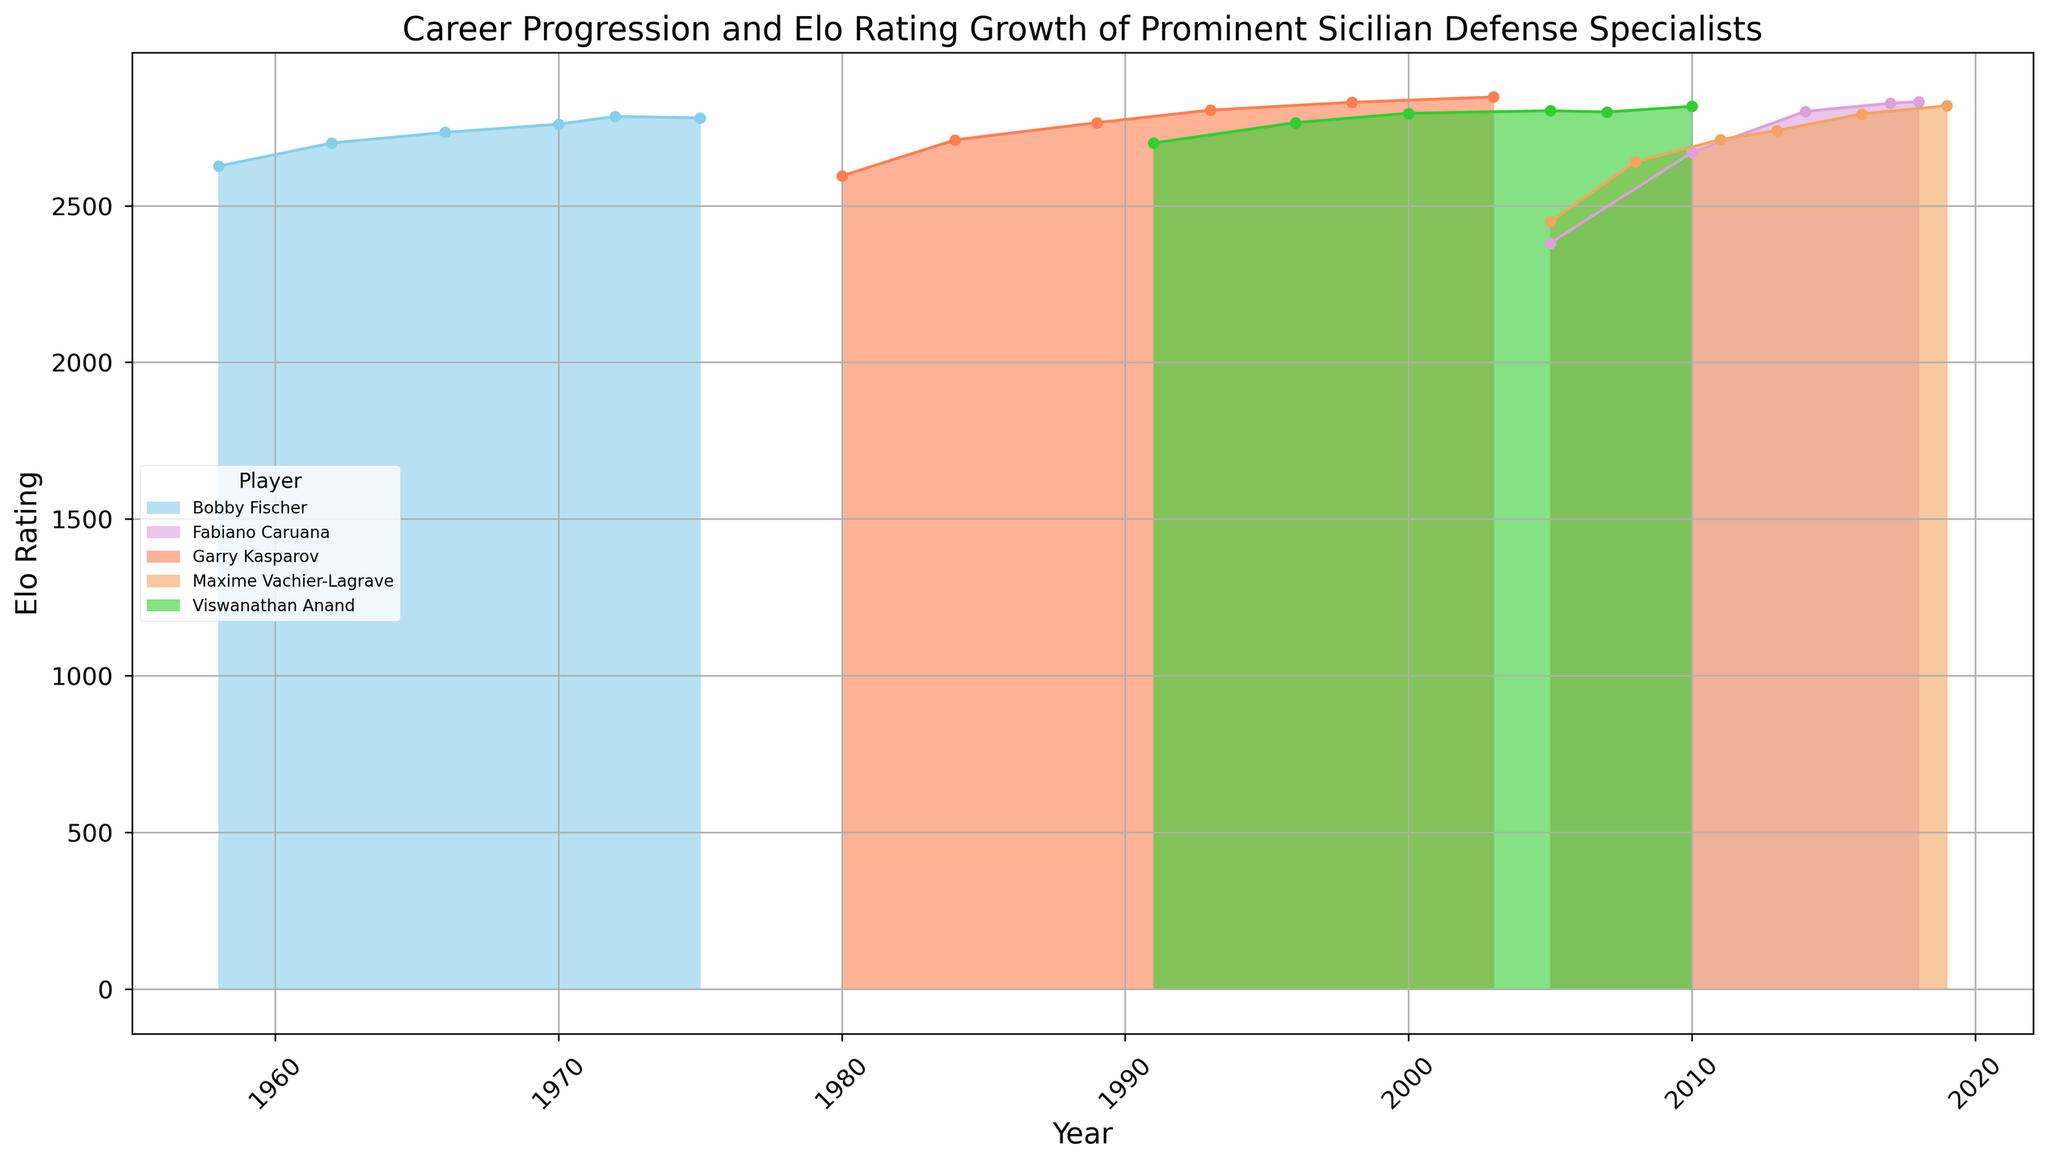What is the highest Elo rating reached by Garry Kasparov, and in which year did he achieve it? Garry Kasparov’s Elo rating peaked at 2847. This can be seen from the highest point of the coral area on the chart in the year 2003.
Answer: 2847, 2003 Compare the Elo rating growth of Bobby Fischer and Viswanathan Anand. Who had a higher rating in 1972 and how much higher was it? In 1972, Bobby Fischer had an Elo rating of 2785 while Viswanathan Anand was not yet represented on the chart, implying Fischer had a rating 2785 points higher than Anand.
Answer: Bobby Fischer, 2785 Which player has the highest recorded Elo rating in the chart and what is that rating? The highest recorded Elo rating belongs to Garry Kasparov with a rating of 2847 in the year 2003. This can be identified by the highest peak in the coral area on the chart.
Answer: Garry Kasparov, 2847 How did Maxime Vachier-Lagrave's rating change between 2005 and 2019? In 2005, Maxime Vachier-Lagrave had an Elo rating of 2449 and in 2019, his rating increased to 2819. The change can be calculated as 2819 - 2449 = 370.
Answer: Increased by 370 Who had a higher Elo rating in 2018, Fabiano Caruana or Maxime Vachier-Lagrave, and by how much? In 2018, Fabiano Caruana had an Elo rating of 2832, while Maxime Vachier-Lagrave had a rating of 2819. The difference is 2832 - 2819 = 13 points, meaning Caruana's rating was 13 points higher.
Answer: Fabiano Caruana, 13 Who among the listed players consistently improved their Elo rating over every recorded period? Fabiano Caruana consistently improved his Elo rating over every recorded period: from 2381 in 2005, to 2670 in 2010, 2801 in 2014, 2827 in 2017, and finally 2832 in 2018. The consistent upward trend in the plum-colored area on the chart confirms this.
Answer: Fabiano Caruana Which two players had an Elo rating over 2800 at some point in their careers, according to the chart? Garry Kasparov and Viswanathan Anand had Elo ratings over 2800 at some points in their careers. Kasparov's rating exceeded 2800 from 1993 onwards, whereas Anand's rating reached 2800 in 2005.
Answer: Garry Kasparov, Viswanathan Anand By how many points did Bobby Fischer's Elo rating increase from his first recorded rating in 1958 to the peak rating in 1972? Bobby Fischer's Elo rating was 2626 in 1958 and peaked at 2785 in 1972. The increase is calculated as 2785 - 2626 = 159 points.
Answer: 159 Which player showed the largest single-time increase in Elo rating and in which period did it occur? The largest single-time increase in Elo rating was shown by Garry Kasparov between 1980 (2595) and 1984 (2710), an increase of 2710 - 2595 = 115 points.
Answer: Garry Kasparov, 1980-1984 